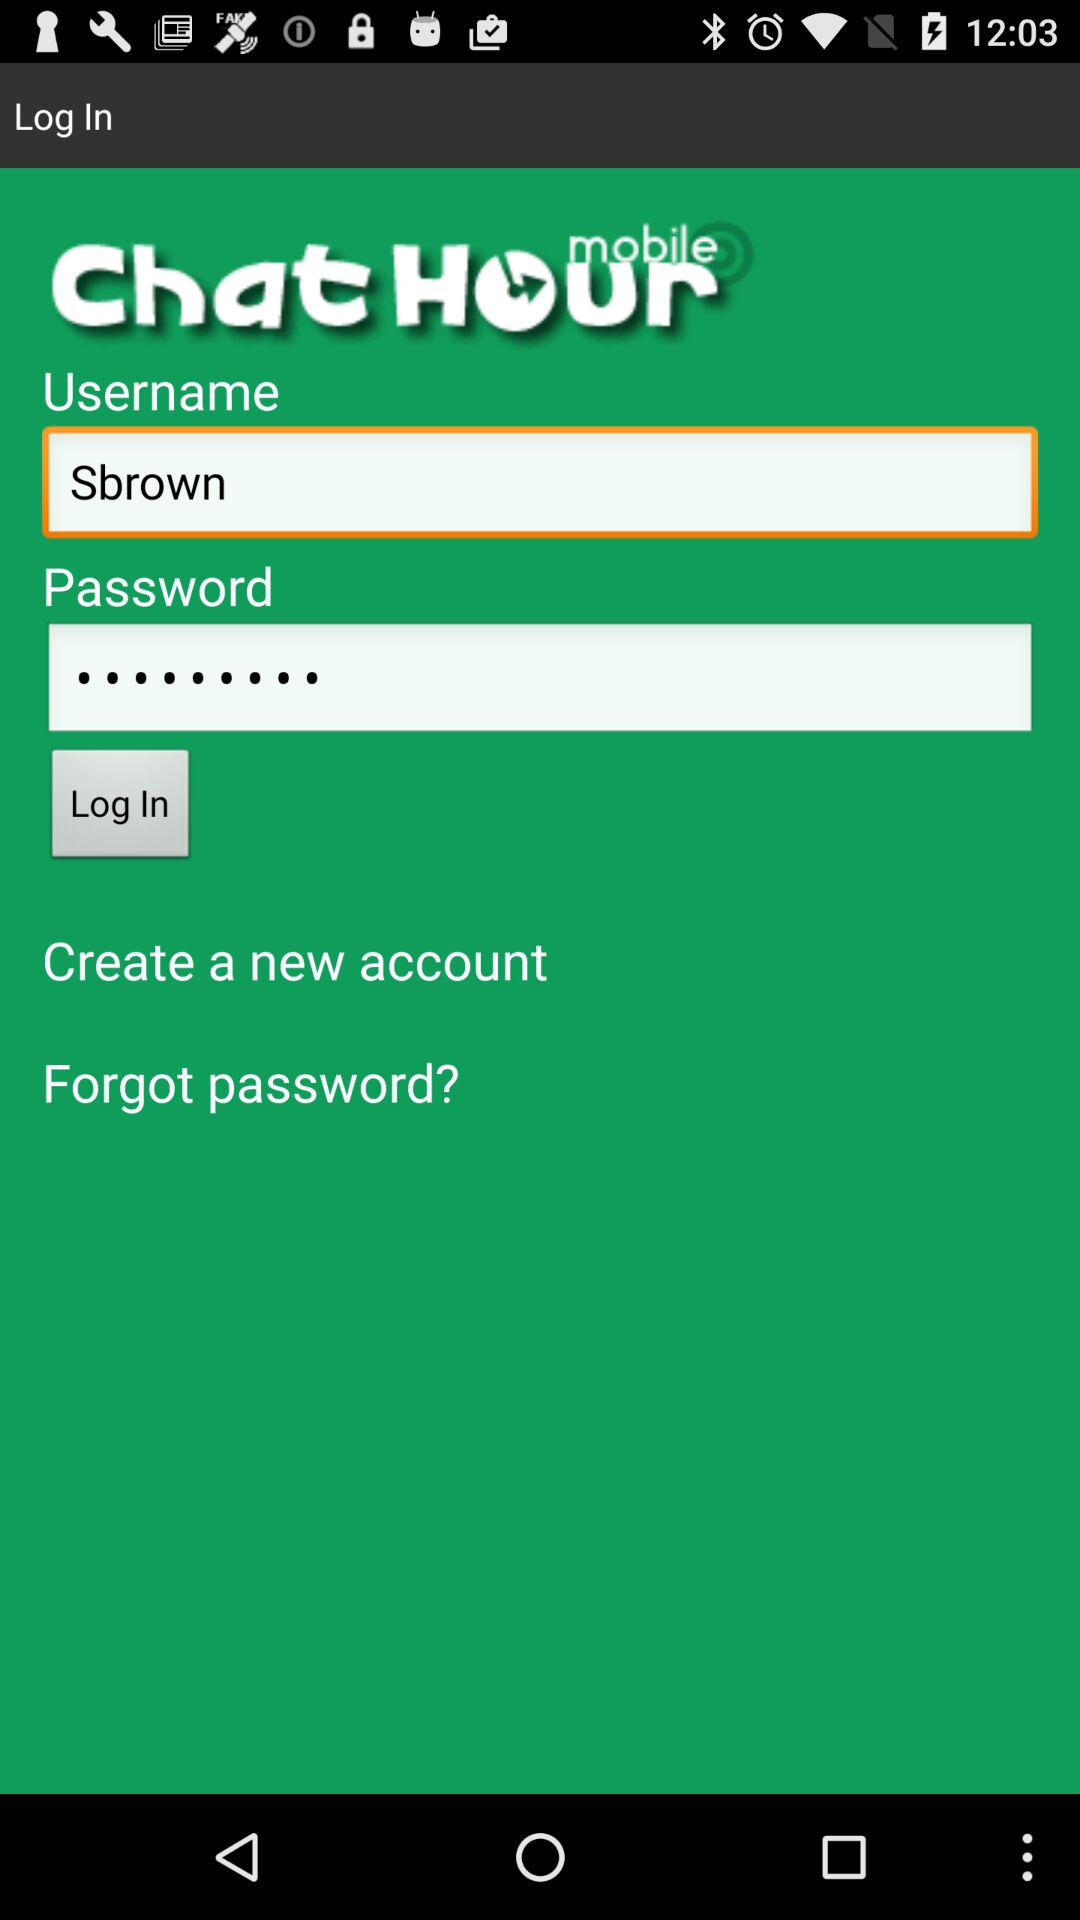What are the requirements to log in? The requirements to log in are "Username" and "Password". 